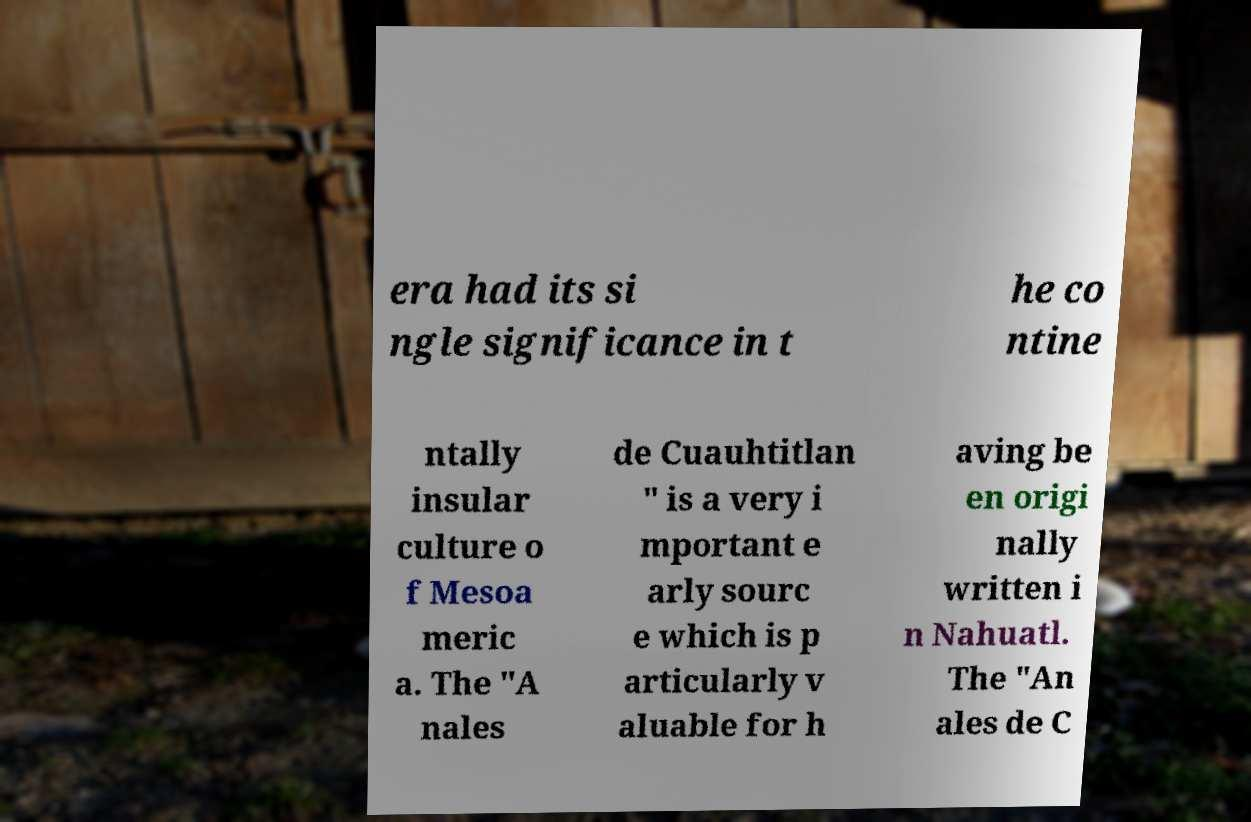What messages or text are displayed in this image? I need them in a readable, typed format. era had its si ngle significance in t he co ntine ntally insular culture o f Mesoa meric a. The "A nales de Cuauhtitlan " is a very i mportant e arly sourc e which is p articularly v aluable for h aving be en origi nally written i n Nahuatl. The "An ales de C 